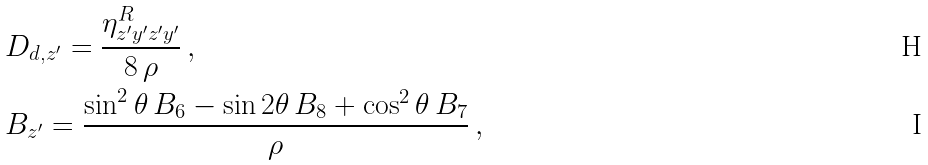Convert formula to latex. <formula><loc_0><loc_0><loc_500><loc_500>& D _ { d , z ^ { \prime } } = \frac { \eta _ { z ^ { \prime } y ^ { \prime } z ^ { \prime } y ^ { \prime } } ^ { R } } { 8 \, \rho } \, , \\ & B _ { z ^ { \prime } } = \frac { \sin ^ { 2 } \theta \, B _ { 6 } - \sin 2 \theta \, B _ { 8 } + \cos ^ { 2 } \theta \, B _ { 7 } } { \rho } \, ,</formula> 